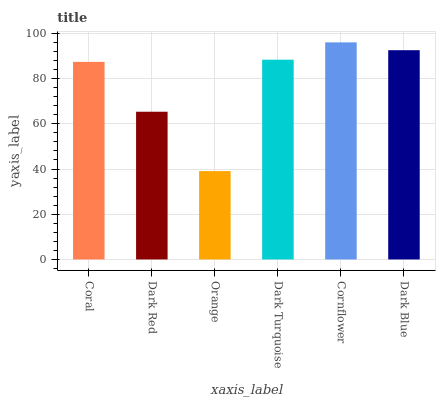Is Orange the minimum?
Answer yes or no. Yes. Is Cornflower the maximum?
Answer yes or no. Yes. Is Dark Red the minimum?
Answer yes or no. No. Is Dark Red the maximum?
Answer yes or no. No. Is Coral greater than Dark Red?
Answer yes or no. Yes. Is Dark Red less than Coral?
Answer yes or no. Yes. Is Dark Red greater than Coral?
Answer yes or no. No. Is Coral less than Dark Red?
Answer yes or no. No. Is Dark Turquoise the high median?
Answer yes or no. Yes. Is Coral the low median?
Answer yes or no. Yes. Is Coral the high median?
Answer yes or no. No. Is Orange the low median?
Answer yes or no. No. 